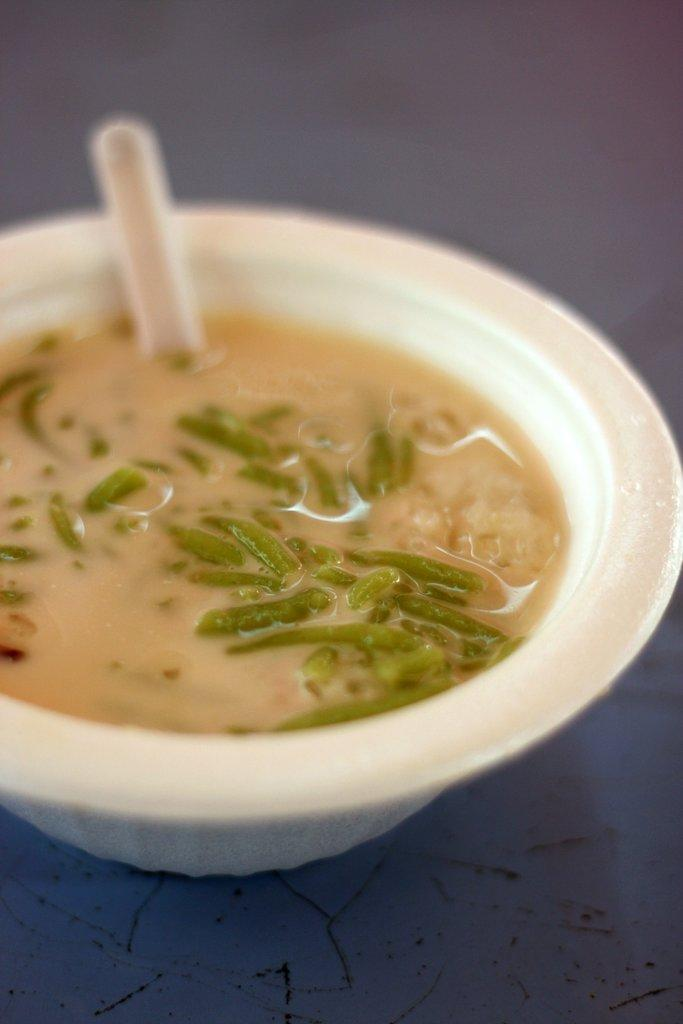What is in the bowl that is visible in the image? The bowl contains a food item. What utensil is present in the image? There is a spoon in the image. What color is the surface on which the bowl and spoon are placed? The bowl and spoon are placed on a blue surface. Are there any farm animals visible in the image? No, there are no farm animals present in the image. Can you see any sand in the image? No, there is no sand visible in the image. 